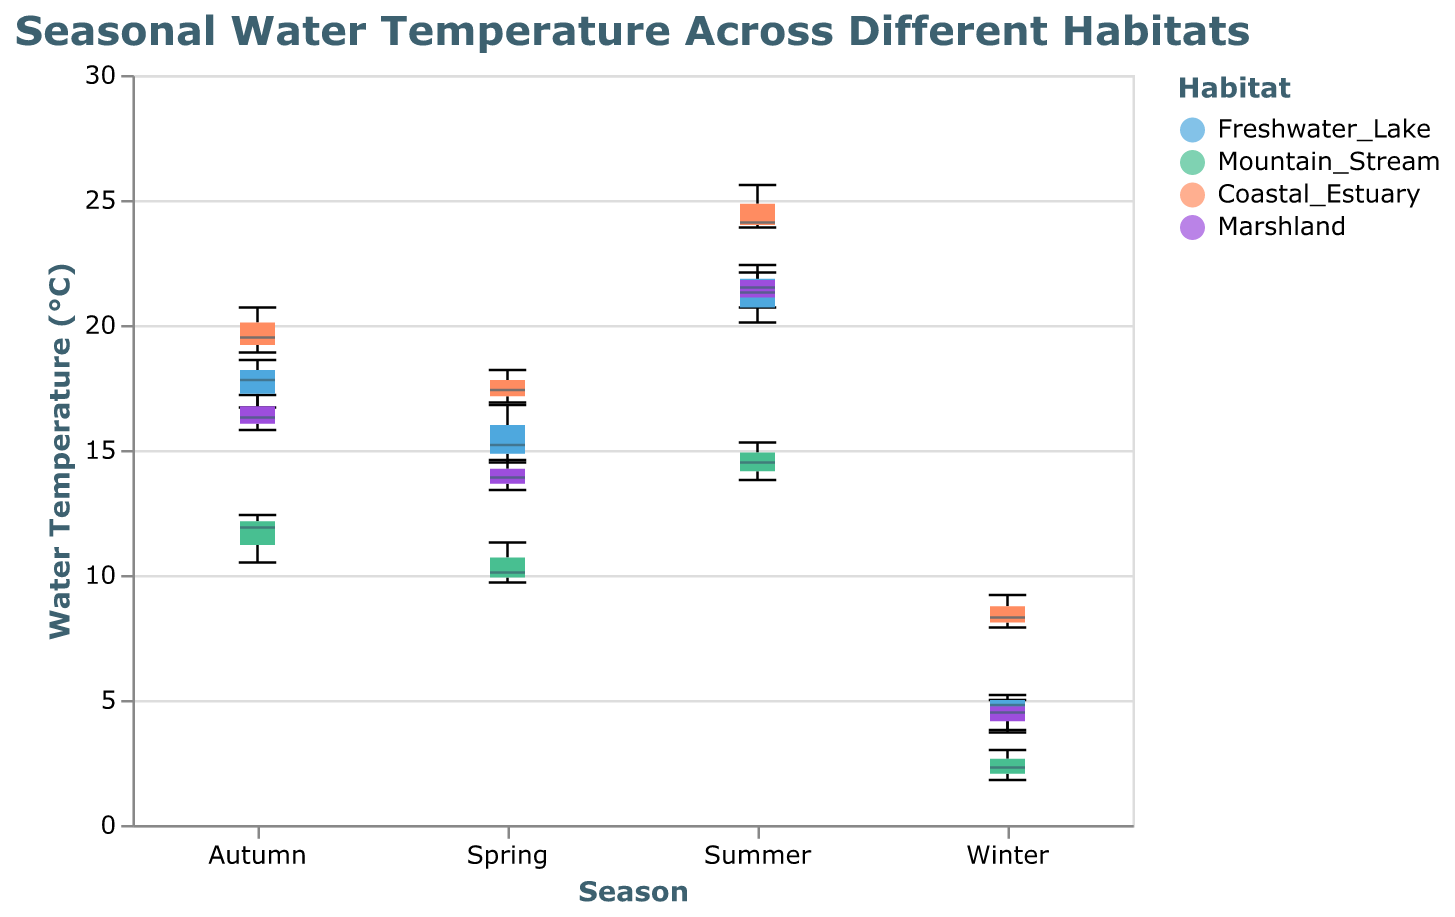What is the median water temperature in Freshwater Lake during the Summer? Look at the box plot for Freshwater Lake in the Summer. The line inside the box represents the median water temperature.
Answer: 21.3°C Which habitat has the highest median water temperature during the Winter? Compare the median lines of all habitats for the Winter season in the box plot. The highest median line indicates the habitat with the highest median temperature.
Answer: Coastal Estuary In which season does the Freshwater Lake have the lowest water temperature range? Look at the length of the boxes (representing the interquartile range) and the whiskers (representing the minimum and maximum values) for Freshwater Lake in each season. The season with the shortest total length indicates the lowest range.
Answer: Winter What is the interquartile range (IQR) of water temperature in Mountain Stream during Autumn? Find the box plot for Mountain Stream in Autumn. The IQR is represented by the range (height) of the box, which spans from the first quartile (bottom of the box) to the third quartile (top of the box).
Answer: 1.9°C (from 10.5°C to 12.4°C) Compare the median water temperatures of Coastal Estuary and Marshland during Summer. Which one is higher? Locate the median lines in the box plots for Coastal Estuary and Marshland during Summer. Compare the two values.
Answer: Coastal Estuary Which season shows the greatest variability in water temperature in the Marshland habitat? Look at the length of the whiskers and the size of the boxes for each season in the Marshland habitat. The season with the longest whiskers and largest box represents the greatest variability.
Answer: Summer How many habitats have a median water temperature below 10°C during Winter? Identify the box plots for each habitat in Winter and count the ones where the median line is below 10°C.
Answer: Three (Freshwater Lake, Mountain Stream, Marshland) What is the difference in median water temperature between Spring and Autumn in Freshwater Lake? Identify the median lines in the box plots for Freshwater Lake in Spring and Autumn. Subtract the Autumn median from the Spring median.
Answer: -1.8°C 